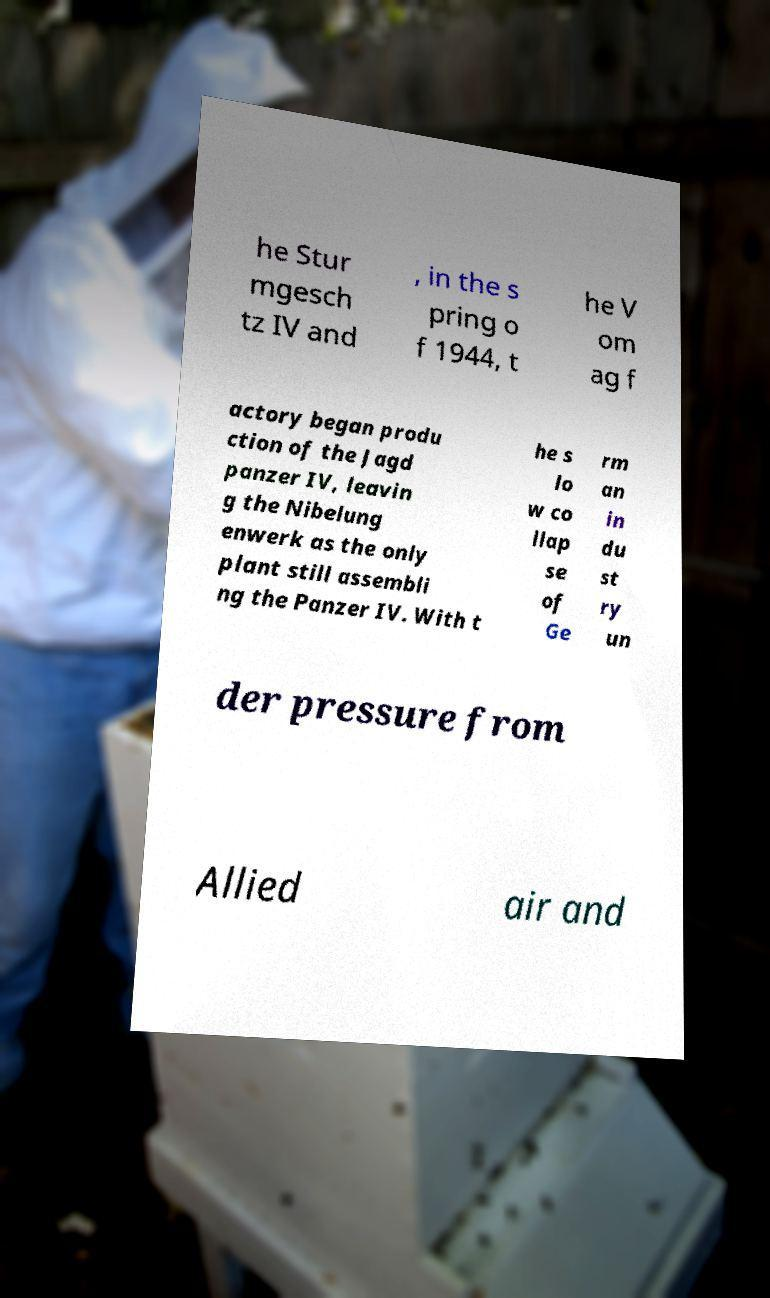Please read and relay the text visible in this image. What does it say? he Stur mgesch tz IV and , in the s pring o f 1944, t he V om ag f actory began produ ction of the Jagd panzer IV, leavin g the Nibelung enwerk as the only plant still assembli ng the Panzer IV. With t he s lo w co llap se of Ge rm an in du st ry un der pressure from Allied air and 